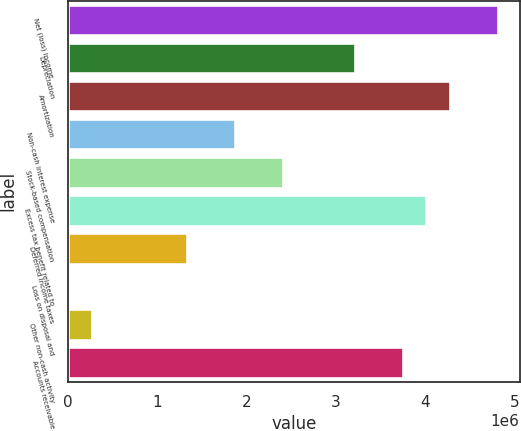Convert chart to OTSL. <chart><loc_0><loc_0><loc_500><loc_500><bar_chart><fcel>Net (loss) income<fcel>Depreciation<fcel>Amortization<fcel>Non-cash interest expense<fcel>Stock-based compensation<fcel>Excess tax benefit related to<fcel>Deferred income taxes<fcel>Loss on disposal and<fcel>Other non-cash activity<fcel>Accounts receivable<nl><fcel>4.81622e+06<fcel>3.21139e+06<fcel>4.28128e+06<fcel>1.87404e+06<fcel>2.40898e+06<fcel>4.01381e+06<fcel>1.3391e+06<fcel>1740<fcel>269211<fcel>3.74634e+06<nl></chart> 